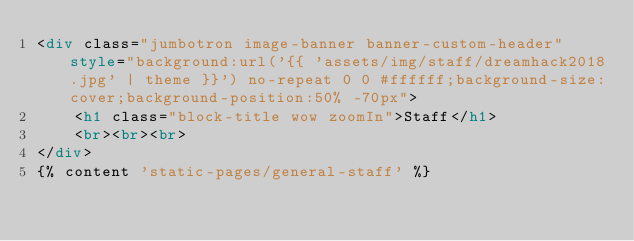<code> <loc_0><loc_0><loc_500><loc_500><_HTML_><div class="jumbotron image-banner banner-custom-header" style="background:url('{{ 'assets/img/staff/dreamhack2018.jpg' | theme }}') no-repeat 0 0 #ffffff;background-size:cover;background-position:50% -70px">
    <h1 class="block-title wow zoomIn">Staff</h1>
    <br><br><br>
</div>
{% content 'static-pages/general-staff' %}</code> 